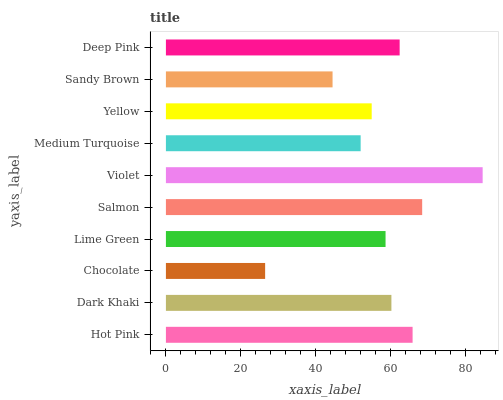Is Chocolate the minimum?
Answer yes or no. Yes. Is Violet the maximum?
Answer yes or no. Yes. Is Dark Khaki the minimum?
Answer yes or no. No. Is Dark Khaki the maximum?
Answer yes or no. No. Is Hot Pink greater than Dark Khaki?
Answer yes or no. Yes. Is Dark Khaki less than Hot Pink?
Answer yes or no. Yes. Is Dark Khaki greater than Hot Pink?
Answer yes or no. No. Is Hot Pink less than Dark Khaki?
Answer yes or no. No. Is Dark Khaki the high median?
Answer yes or no. Yes. Is Lime Green the low median?
Answer yes or no. Yes. Is Yellow the high median?
Answer yes or no. No. Is Yellow the low median?
Answer yes or no. No. 